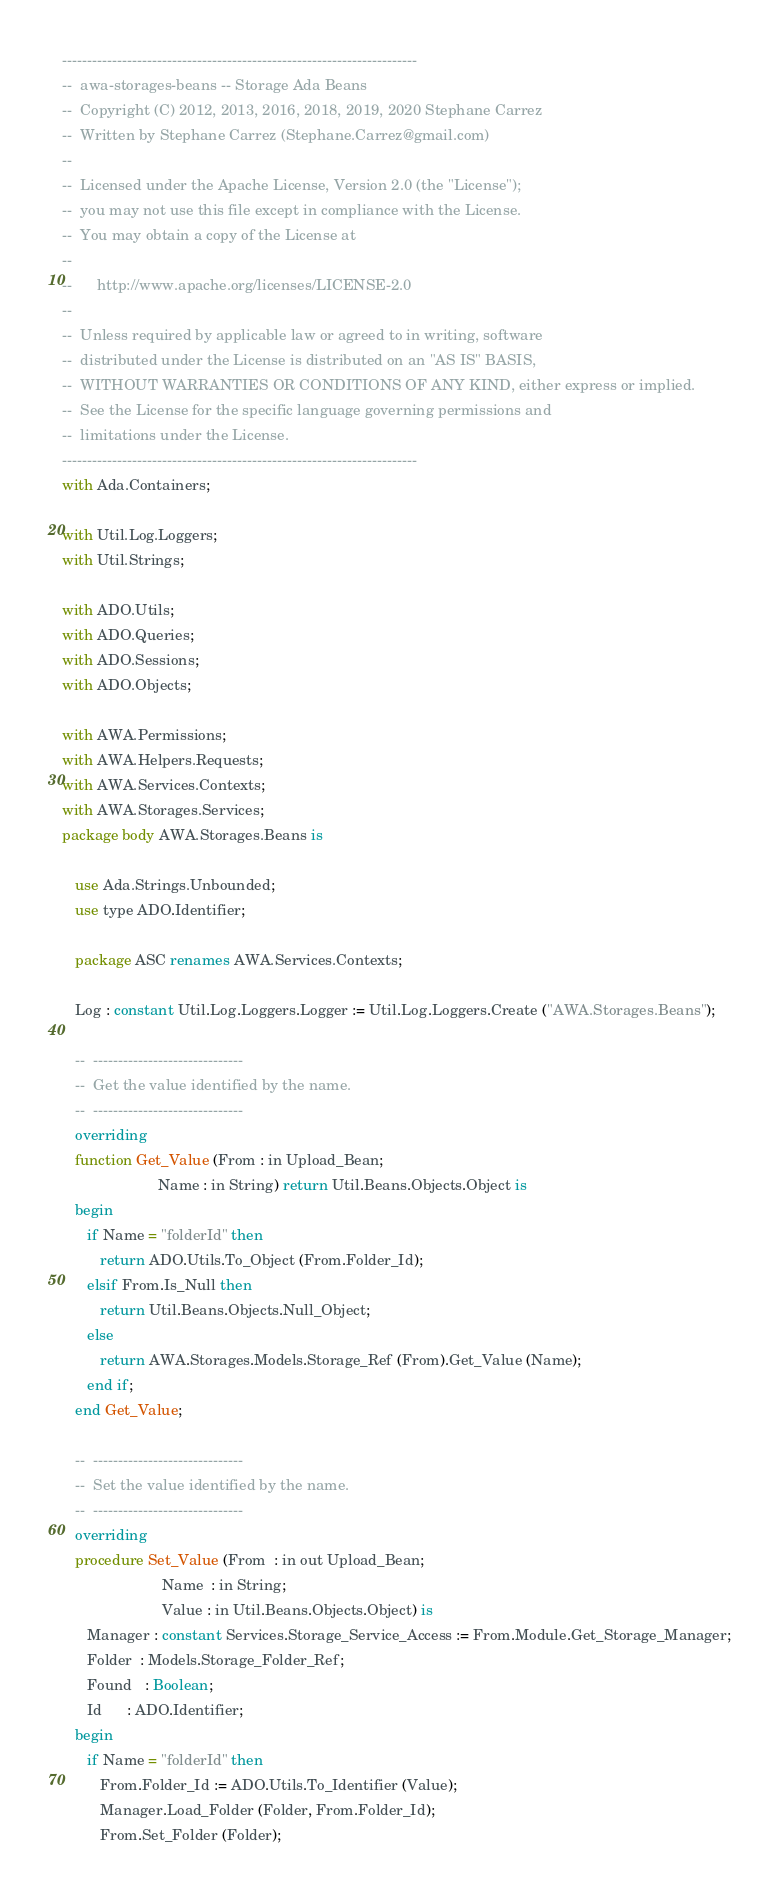Convert code to text. <code><loc_0><loc_0><loc_500><loc_500><_Ada_>-----------------------------------------------------------------------
--  awa-storages-beans -- Storage Ada Beans
--  Copyright (C) 2012, 2013, 2016, 2018, 2019, 2020 Stephane Carrez
--  Written by Stephane Carrez (Stephane.Carrez@gmail.com)
--
--  Licensed under the Apache License, Version 2.0 (the "License");
--  you may not use this file except in compliance with the License.
--  You may obtain a copy of the License at
--
--      http://www.apache.org/licenses/LICENSE-2.0
--
--  Unless required by applicable law or agreed to in writing, software
--  distributed under the License is distributed on an "AS IS" BASIS,
--  WITHOUT WARRANTIES OR CONDITIONS OF ANY KIND, either express or implied.
--  See the License for the specific language governing permissions and
--  limitations under the License.
-----------------------------------------------------------------------
with Ada.Containers;

with Util.Log.Loggers;
with Util.Strings;

with ADO.Utils;
with ADO.Queries;
with ADO.Sessions;
with ADO.Objects;

with AWA.Permissions;
with AWA.Helpers.Requests;
with AWA.Services.Contexts;
with AWA.Storages.Services;
package body AWA.Storages.Beans is

   use Ada.Strings.Unbounded;
   use type ADO.Identifier;

   package ASC renames AWA.Services.Contexts;

   Log : constant Util.Log.Loggers.Logger := Util.Log.Loggers.Create ("AWA.Storages.Beans");

   --  ------------------------------
   --  Get the value identified by the name.
   --  ------------------------------
   overriding
   function Get_Value (From : in Upload_Bean;
                       Name : in String) return Util.Beans.Objects.Object is
   begin
      if Name = "folderId" then
         return ADO.Utils.To_Object (From.Folder_Id);
      elsif From.Is_Null then
         return Util.Beans.Objects.Null_Object;
      else
         return AWA.Storages.Models.Storage_Ref (From).Get_Value (Name);
      end if;
   end Get_Value;

   --  ------------------------------
   --  Set the value identified by the name.
   --  ------------------------------
   overriding
   procedure Set_Value (From  : in out Upload_Bean;
                        Name  : in String;
                        Value : in Util.Beans.Objects.Object) is
      Manager : constant Services.Storage_Service_Access := From.Module.Get_Storage_Manager;
      Folder  : Models.Storage_Folder_Ref;
      Found   : Boolean;
      Id      : ADO.Identifier;
   begin
      if Name = "folderId" then
         From.Folder_Id := ADO.Utils.To_Identifier (Value);
         Manager.Load_Folder (Folder, From.Folder_Id);
         From.Set_Folder (Folder);</code> 